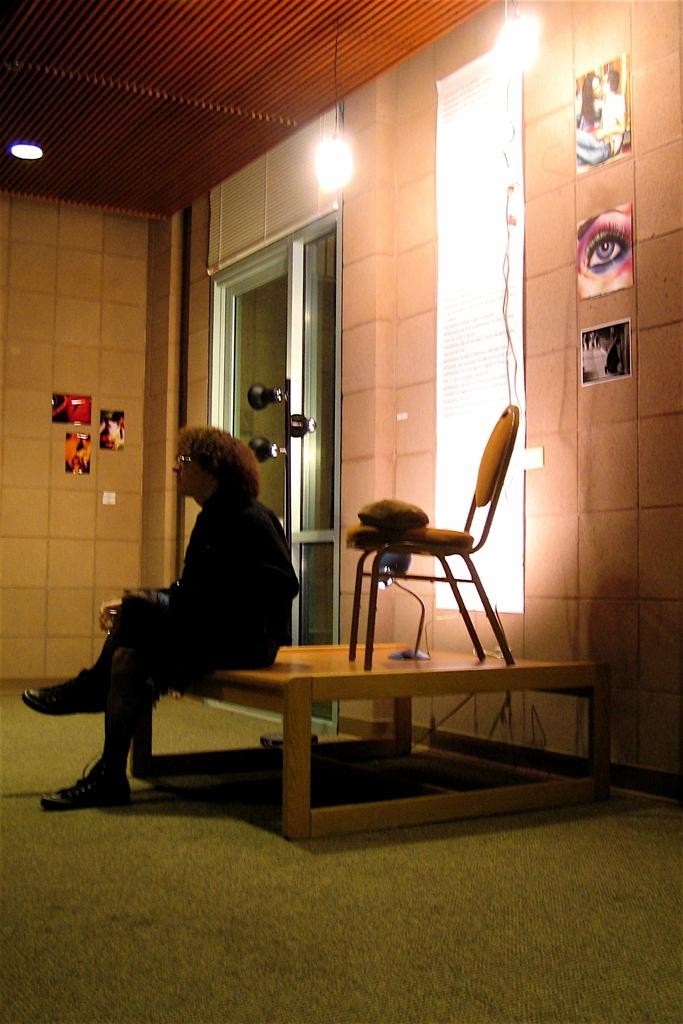What is the woman doing in the image? The woman is seated on a table in the image. What piece of furniture is near the woman? There is a chair in the image. What can be used to provide illumination in the image? A light is present in the image. What is visible on the wall in the background? There are photos on the wall in the background. What else can be seen in the background that provides illumination? There are lights visible in the background. What type of corn is being harvested by the woman in the image? There is no corn present in the image; the woman is seated on a table. 